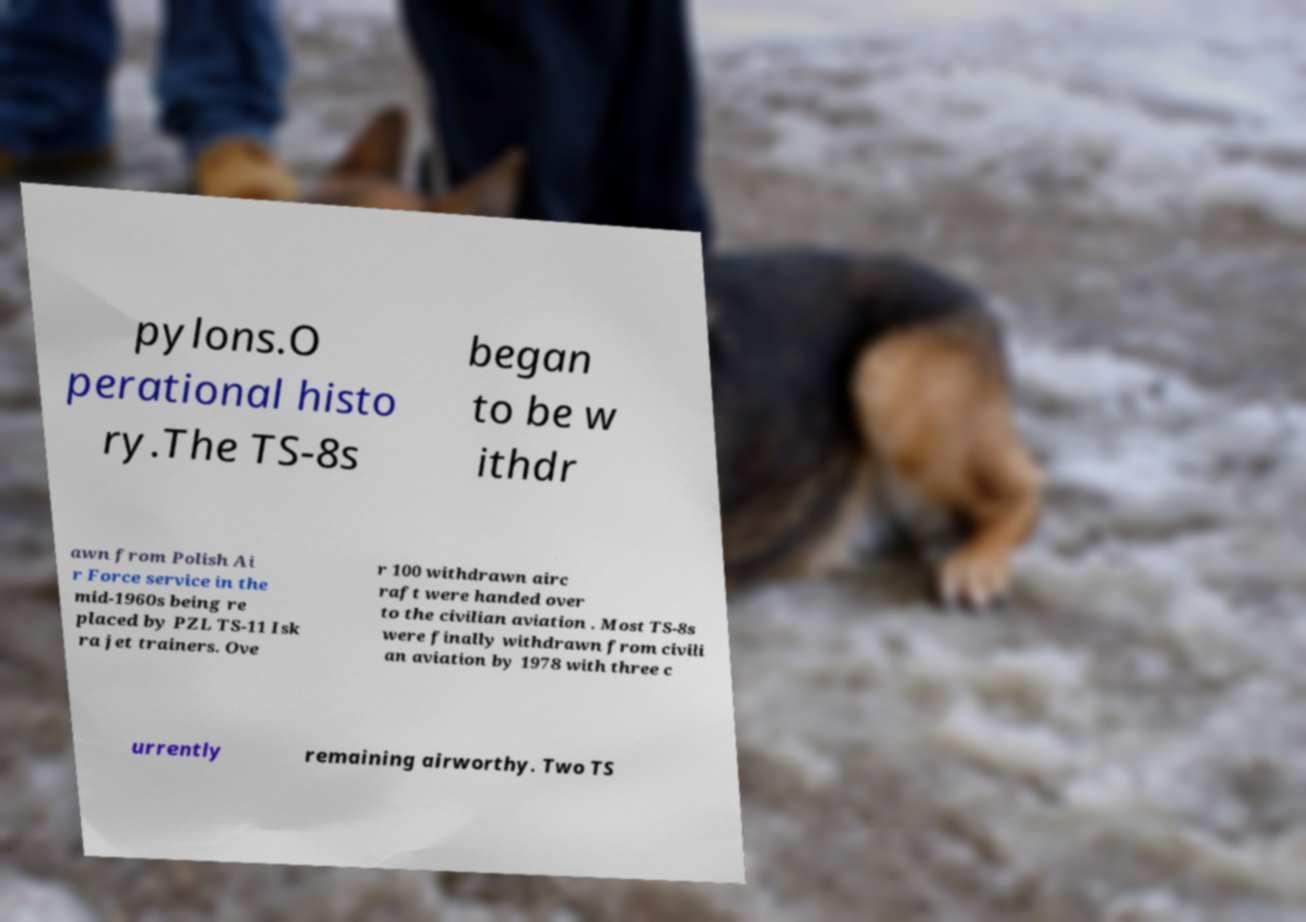For documentation purposes, I need the text within this image transcribed. Could you provide that? pylons.O perational histo ry.The TS-8s began to be w ithdr awn from Polish Ai r Force service in the mid-1960s being re placed by PZL TS-11 Isk ra jet trainers. Ove r 100 withdrawn airc raft were handed over to the civilian aviation . Most TS-8s were finally withdrawn from civili an aviation by 1978 with three c urrently remaining airworthy. Two TS 